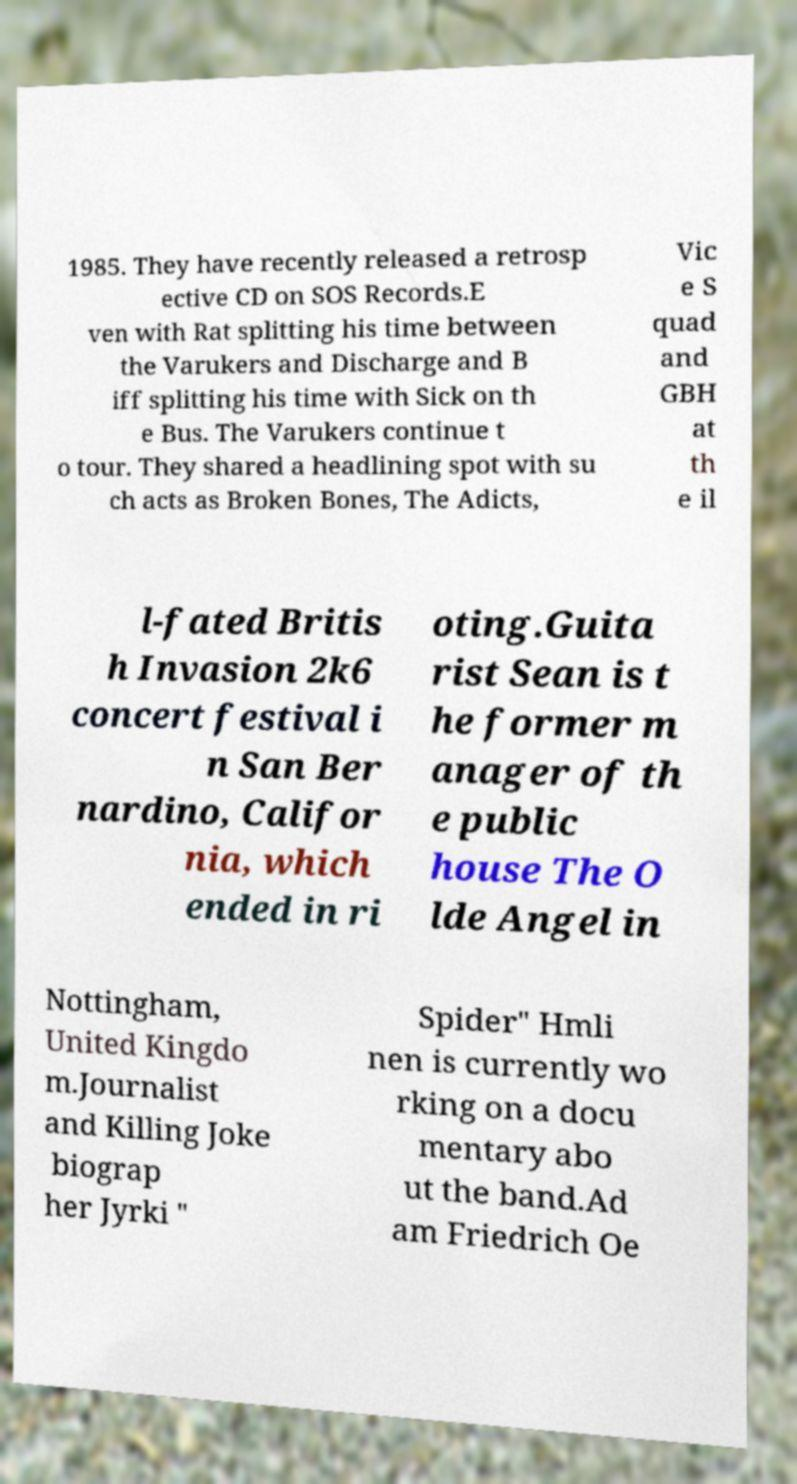There's text embedded in this image that I need extracted. Can you transcribe it verbatim? 1985. They have recently released a retrosp ective CD on SOS Records.E ven with Rat splitting his time between the Varukers and Discharge and B iff splitting his time with Sick on th e Bus. The Varukers continue t o tour. They shared a headlining spot with su ch acts as Broken Bones, The Adicts, Vic e S quad and GBH at th e il l-fated Britis h Invasion 2k6 concert festival i n San Ber nardino, Califor nia, which ended in ri oting.Guita rist Sean is t he former m anager of th e public house The O lde Angel in Nottingham, United Kingdo m.Journalist and Killing Joke biograp her Jyrki " Spider" Hmli nen is currently wo rking on a docu mentary abo ut the band.Ad am Friedrich Oe 